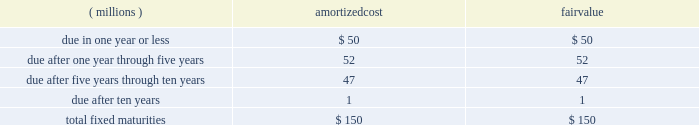Notes to consolidated financial statements the amortized cost and fair value of fixed maturities by contractual maturity as of december 31 , 2007 , are as follows : amortized fair ( millions ) cost value .
Expected maturities may differ from contractual maturities because borrowers may have the right to call or prepay obligations with or without call or prepayment penalties .
For categorization purposes , aon considers any rating of baa or higher by moody 2019s investor services or equivalent rating agency to be investment grade .
Aon 2019s continuing operations have no fixed maturities with an unrealized loss at december 31 , 2007 .
Aon 2019s fixed-maturity portfolio is subject to interest rate , market and credit risks .
With a carrying value of approximately $ 150 million at december 31 , 2007 , aon 2019s total fixed-maturity portfolio is approximately 96% ( 96 % ) investment grade based on market value .
Aon 2019s non publicly-traded fixed maturity portfolio had a carrying value of $ 9 million .
Valuations of these securities primarily reflect the fundamental analysis of the issuer and current market price of comparable securities .
Aon 2019s equity portfolio is comprised of a preferred stock not publicly traded .
This portfolio is subject to interest rate , market , credit , illiquidity , concentration and operational performance risks .
Limited partnership securitization .
In 2001 , aon sold the vast majority of its limited partnership ( lp ) portfolio , valued at $ 450 million , to peps i , a qspe .
The common stock interest in peps i is held by a limited liability company which is owned by aon ( 49% ( 49 % ) ) and by a charitable trust , which is not controlled by aon , established for victims of september 11 ( 51% ( 51 % ) ) .
Approximately $ 171 million of investment grade fixed-maturity securities were sold by peps i to unaffiliated third parties .
Peps i then paid aon 2019s insurance underwriting subsidiaries the $ 171 million in cash and issued to them an additional $ 279 million in fixed-maturity and preferred stock securities .
As part of this transaction , aon is required to purchase from peps i additional fixed-maturity securities in an amount equal to the unfunded limited partnership commitments , as they are requested .
Aon funded $ 2 million of commitments in both 2007 and 2006 .
As of december 31 , 2007 , these unfunded commitments amounted to $ 44 million .
These commitments have specific expiration dates and the general partners may decide not to draw on these commitments .
The carrying value of the peps i preferred stock was $ 168 million and $ 210 million at december 31 , 2007 and 2006 , respectively .
Prior to 2007 , income distributions received from peps i were limited to interest payments on various peps i debt instruments .
Beginning in 2007 , peps i had redeemed or collateralized all of its debt , and as a result , began to pay preferred income distributions .
In 2007 , the company received $ 61 million of income distributions from peps i , which are included in investment income .
Aon corporation .
What is the percentage of the amortized cost of contracts due in one year or less among the total? 
Rationale: it is the value of those contracts divided by the total , then turned into a percentage .
Computations: (50 / 150)
Answer: 0.33333. 